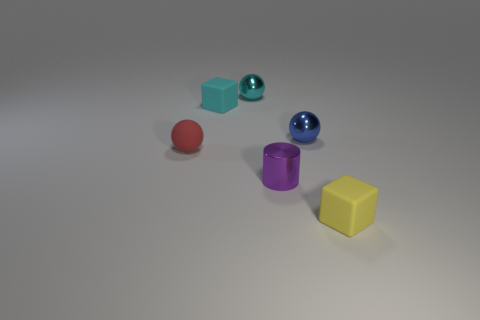Do the yellow object and the ball to the right of the purple metallic thing have the same material?
Offer a very short reply. No. What number of objects are spheres that are on the right side of the purple shiny cylinder or yellow matte objects?
Keep it short and to the point. 2. Is there a matte ball that has the same color as the tiny metal cylinder?
Make the answer very short. No. Do the tiny blue object and the tiny shiny thing that is behind the blue metal sphere have the same shape?
Offer a terse response. Yes. What number of rubber things are both behind the small red ball and in front of the cylinder?
Your answer should be compact. 0. There is a small red thing that is the same shape as the blue thing; what is it made of?
Offer a terse response. Rubber. There is a rubber block to the right of the shiny object that is left of the purple metal cylinder; what size is it?
Offer a terse response. Small. Are there any blue spheres?
Provide a short and direct response. Yes. What is the small sphere that is both in front of the tiny cyan metallic object and to the left of the small purple metal cylinder made of?
Give a very brief answer. Rubber. Is the number of metallic objects to the left of the cyan rubber block greater than the number of small purple cylinders left of the small yellow rubber block?
Provide a short and direct response. No. 